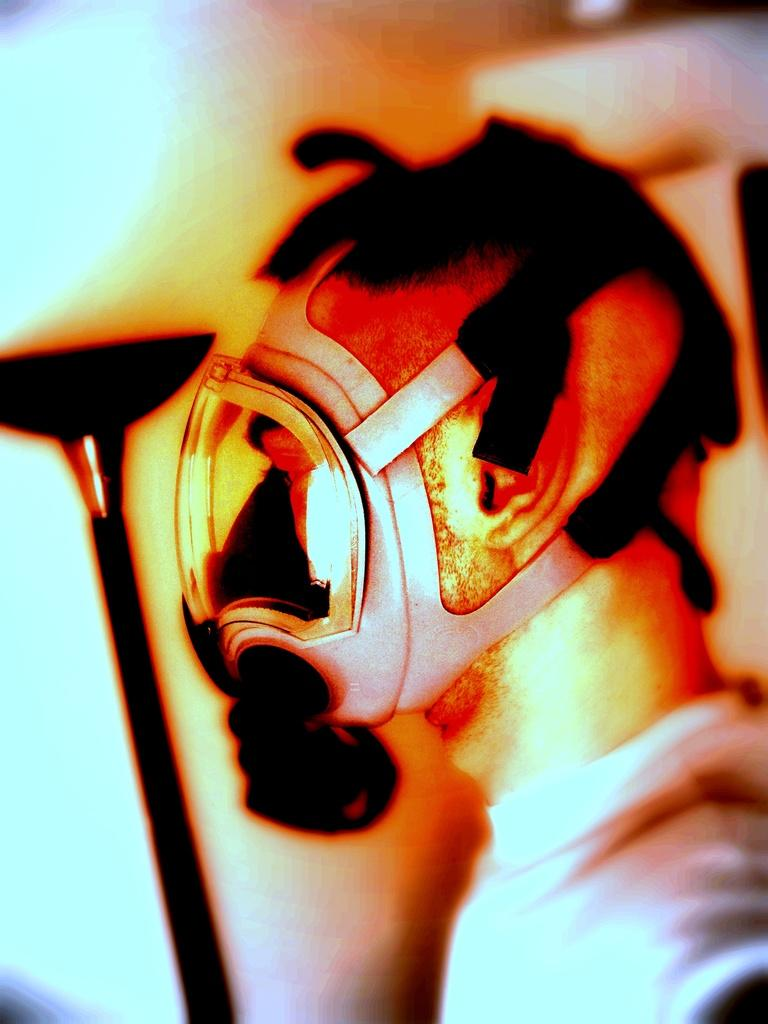Who is present in the image? There is a man in the image. What is the man wearing on his face? The man is wearing a mask. Can you describe the object in the image? Unfortunately, the provided facts do not give enough information to describe the object in the image. What type of ear is visible on the man's face in the image? There is no ear visible on the man's face in the image, as he is wearing a mask that covers his face. What kind of party is the man attending in the image? There is no information about a party in the image, nor is there any indication that the man is attending one. 